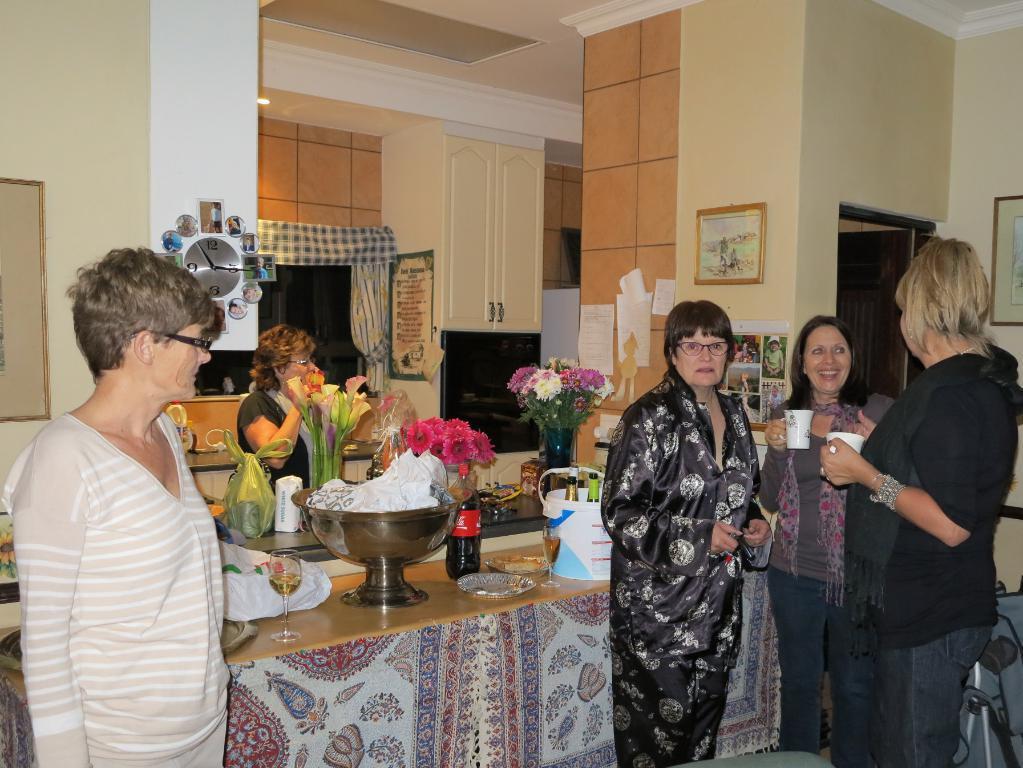Please provide a concise description of this image. These 4 persons are standing. On this table there is a container, flowers with vase, plate, bottles, bucket and things. A clock on wall. These are pictures on wall. On wall there are posters. 